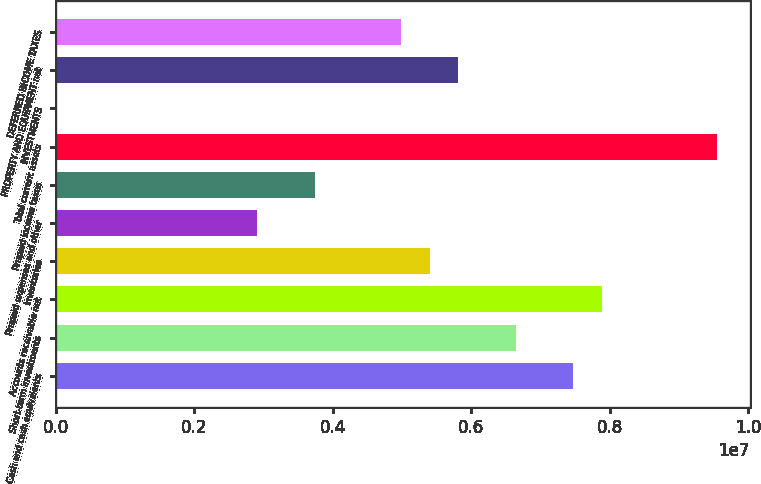<chart> <loc_0><loc_0><loc_500><loc_500><bar_chart><fcel>Cash and cash equivalents<fcel>Short-term investments<fcel>Accounts receivable net<fcel>Inventories<fcel>Prepaid expenses and other<fcel>Prepaid income taxes<fcel>Total current assets<fcel>INVESTMENTS<fcel>PROPERTY AND EQUIPMENT net<fcel>DEFERRED INCOME TAXES<nl><fcel>7.47433e+06<fcel>6.64412e+06<fcel>7.88944e+06<fcel>5.39879e+06<fcel>2.90815e+06<fcel>3.73836e+06<fcel>9.54987e+06<fcel>2394<fcel>5.8139e+06<fcel>4.98369e+06<nl></chart> 